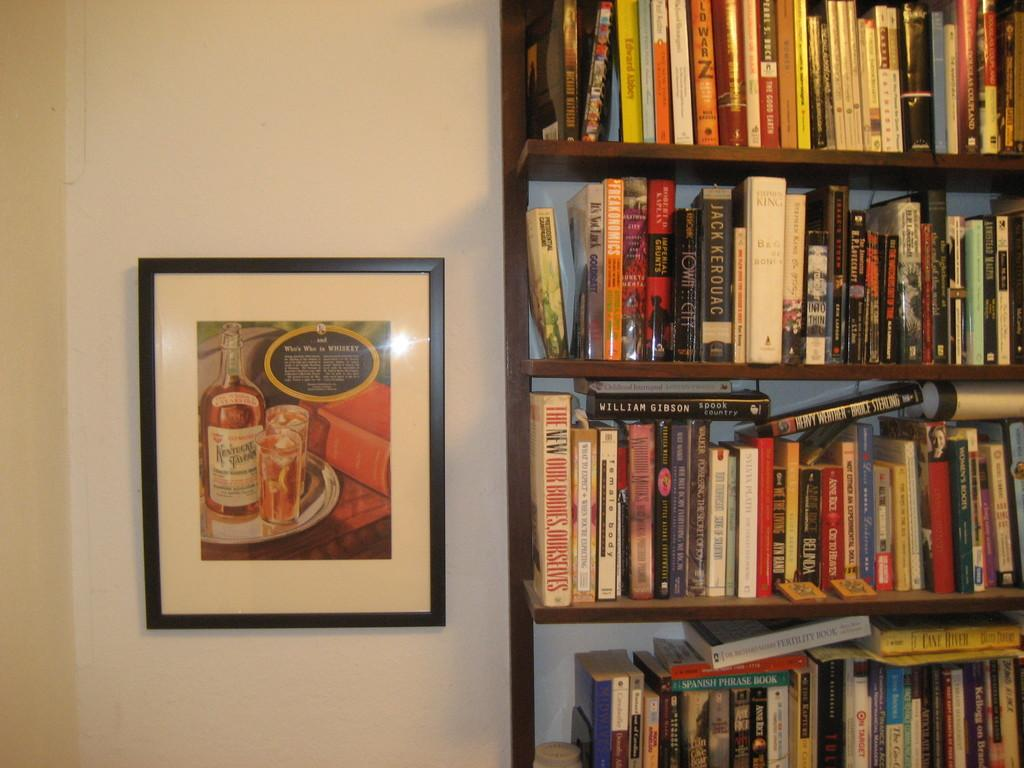What type of objects can be seen in the racks in the image? There are books in the racks in the image. Can you describe the object on the wall on the left side of the image? There is a frame on the wall on the left side of the image. Where is the toad sitting in the image? There is no toad present in the image. What color is the cap on the sofa in the image? There is no cap or sofa present in the image. 